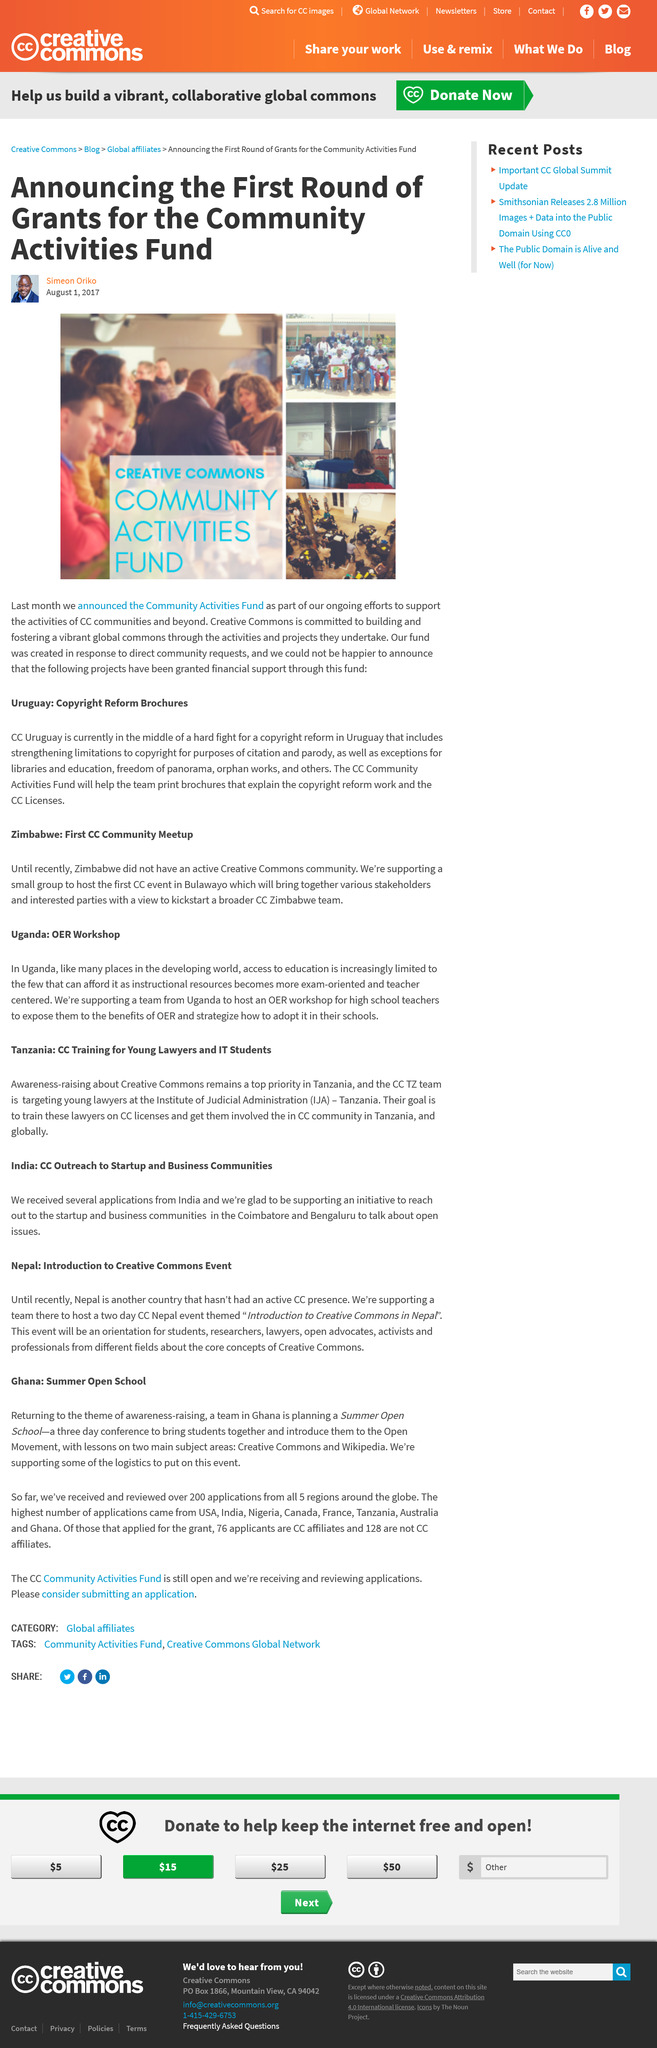Specify some key components in this picture. This fund was established in response to explicit community demands. The highest number of applications came from the United States of America, India, Nigeria, Canada, France, Tanzania, Australia, and Ghana. The committee has received and reviewed a total of 200 applications from all five regions globally. The article was written by Simeon Oriko. CC" is an abbreviation that stands for "Creative Commons." This is a declaration of fact, as it is a widely recognized and commonly used acronym. 